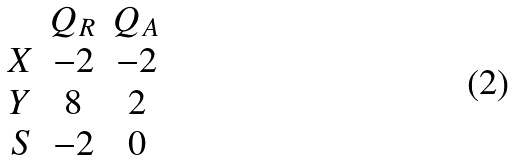Convert formula to latex. <formula><loc_0><loc_0><loc_500><loc_500>\begin{array} { c c c } & Q _ { R } & Q _ { A } \\ X & - 2 & - 2 \\ Y & 8 & 2 \\ S & - 2 & 0 \\ \end{array}</formula> 